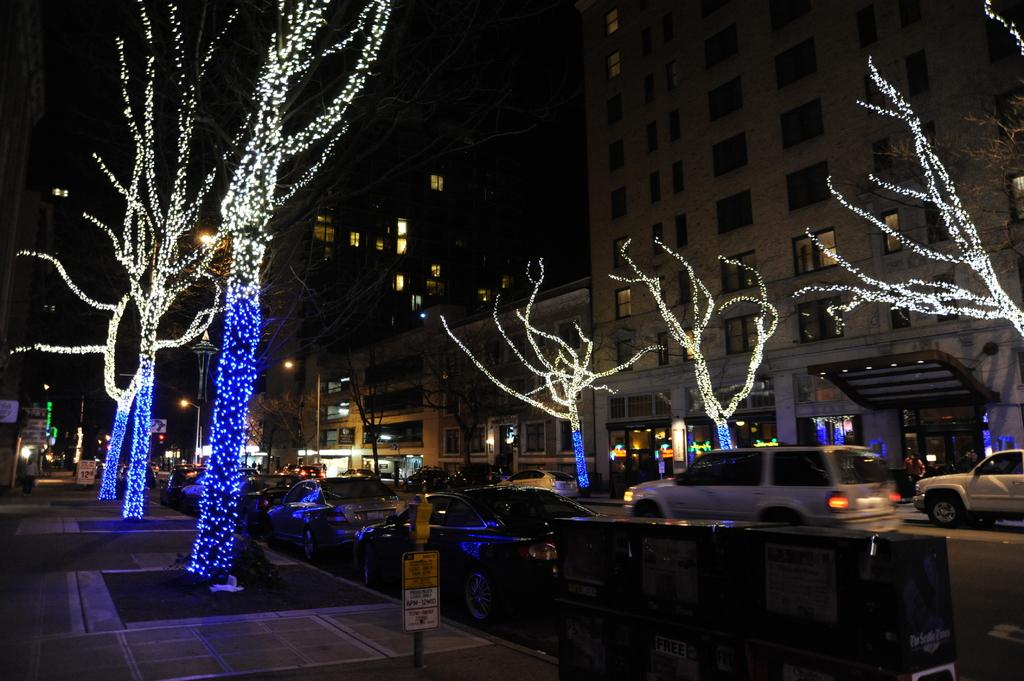What type of decoration can be seen on both sides of the road in the image? There is tree light decoration on both sides of the road. What is moving along the road in the image? There are cars on the road. What structures are visible in the middle of the image? There are buildings in the middle of the image. What type of lace can be seen on the buildings in the image? There is no lace visible on the buildings in the image. What story is being told by the cars on the road in the image? The image does not depict a story; it is a static representation of cars on the road with tree light decorations and buildings. 